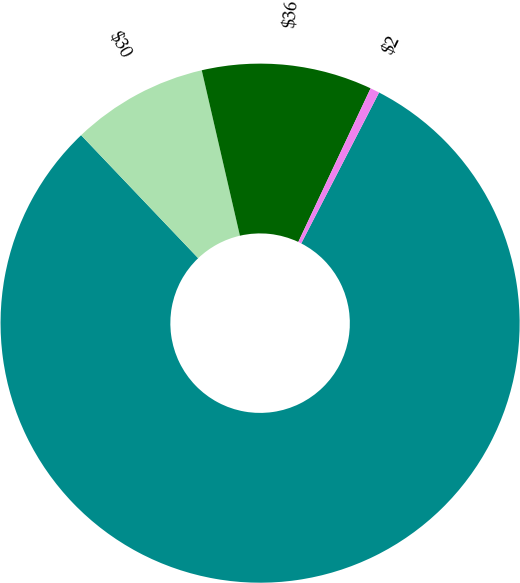Convert chart. <chart><loc_0><loc_0><loc_500><loc_500><pie_chart><ecel><fcel>$30<fcel>$36<fcel>$2<nl><fcel>80.31%<fcel>8.5%<fcel>10.61%<fcel>0.58%<nl></chart> 